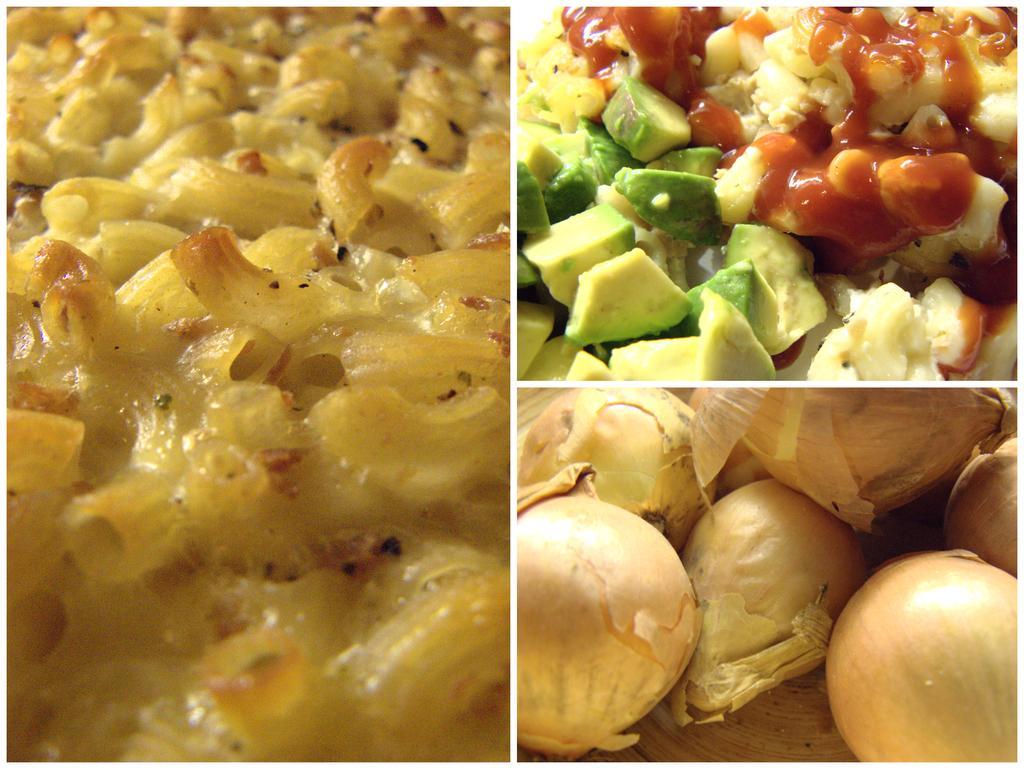In one or two sentences, can you explain what this image depicts? This is a collage of three different pictures with food items. 